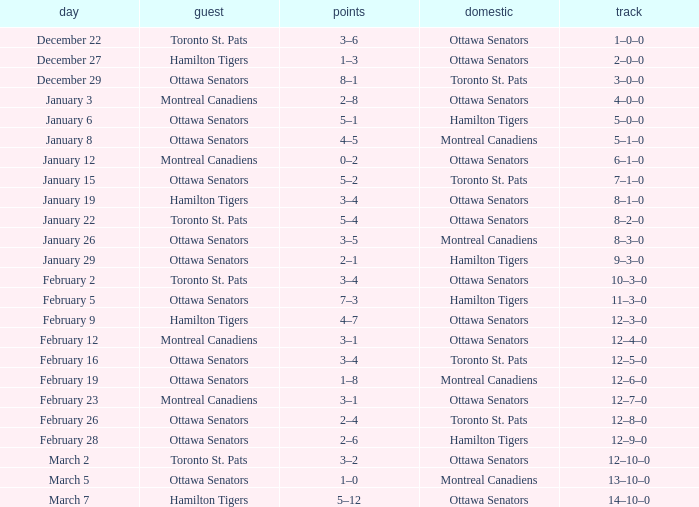Who was the home team when the vistor team was the Montreal Canadiens on February 12? Ottawa Senators. 